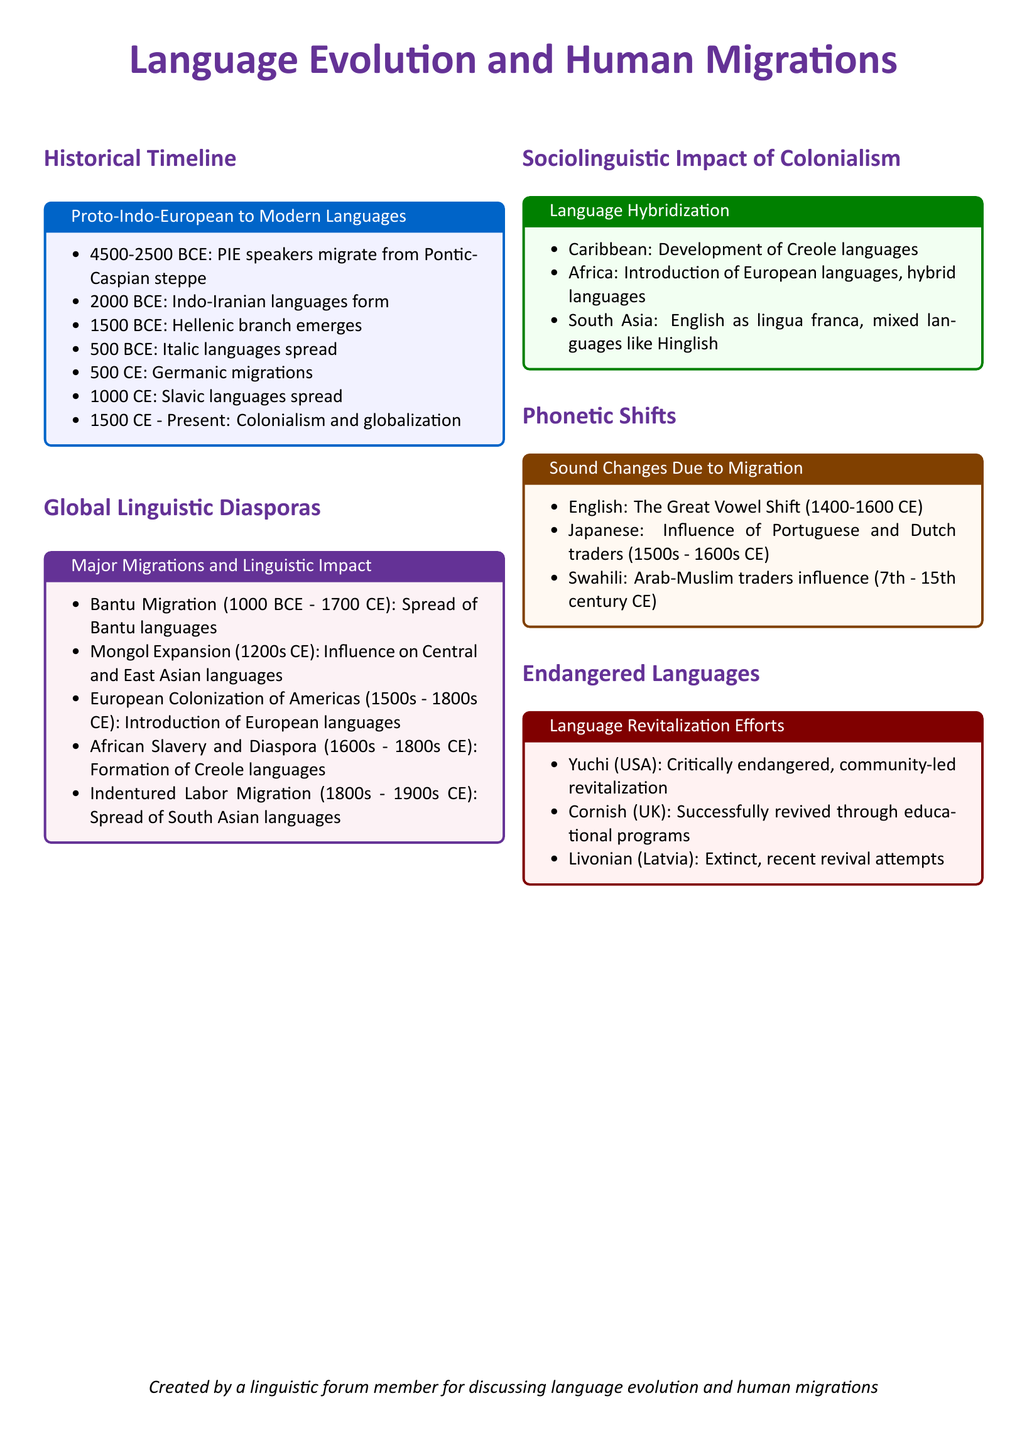What is the time period for Proto-Indo-European migration? The document states that Proto-Indo-European speakers migrated from the Pontic-Caspian steppe during the time period of 4500-2500 BCE.
Answer: 4500-2500 BCE What language branch emerged around 1500 BCE? The timeline indicates that the Hellenic branch emerged around 1500 BCE.
Answer: Hellenic Which migration is associated with the spread of Bantu languages? The fact sheet highlights the Bantu Migration from 1000 BCE to 1700 CE as influential in the spread of Bantu languages.
Answer: Bantu Migration What language hybridization developed in the Caribbean? The document mentions the development of Creole languages as a result of language hybridization in the Caribbean.
Answer: Creole languages What significant vowel shift occurred in English? The Great Vowel Shift is noted as a significant phonetic change in English between 1400-1600 CE.
Answer: Great Vowel Shift Which language is critically endangered and has community-led revitalization efforts? According to the document, the Yuchi language in the USA is critically endangered and undergoing community-led revitalization.
Answer: Yuchi What was the impact of the African Diaspora on language? The document states that the African Diaspora led to the formation of Creole languages.
Answer: Creole languages When did European colonization of the Americas occur? The migration period categorized as the European Colonization of the Americas is stated as occurring from the 1500s to the 1800s CE.
Answer: 1500s - 1800s CE What type of changes does the document discuss under phonetic shifts? Phonetic shifts discussed include sound changes due to migration and cultural interactions across different languages.
Answer: Sound changes due to migration and cultural interactions 